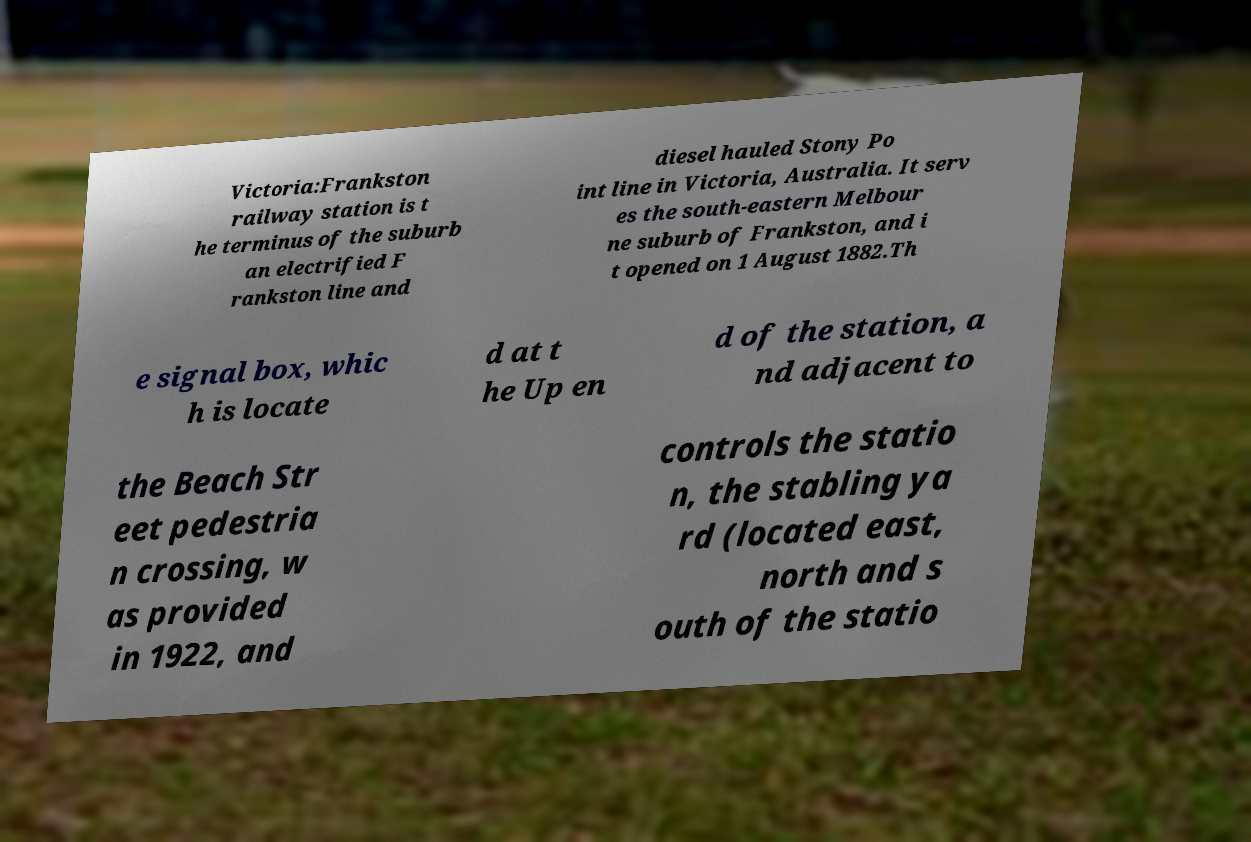Can you read and provide the text displayed in the image?This photo seems to have some interesting text. Can you extract and type it out for me? Victoria:Frankston railway station is t he terminus of the suburb an electrified F rankston line and diesel hauled Stony Po int line in Victoria, Australia. It serv es the south-eastern Melbour ne suburb of Frankston, and i t opened on 1 August 1882.Th e signal box, whic h is locate d at t he Up en d of the station, a nd adjacent to the Beach Str eet pedestria n crossing, w as provided in 1922, and controls the statio n, the stabling ya rd (located east, north and s outh of the statio 